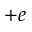<formula> <loc_0><loc_0><loc_500><loc_500>+ e</formula> 